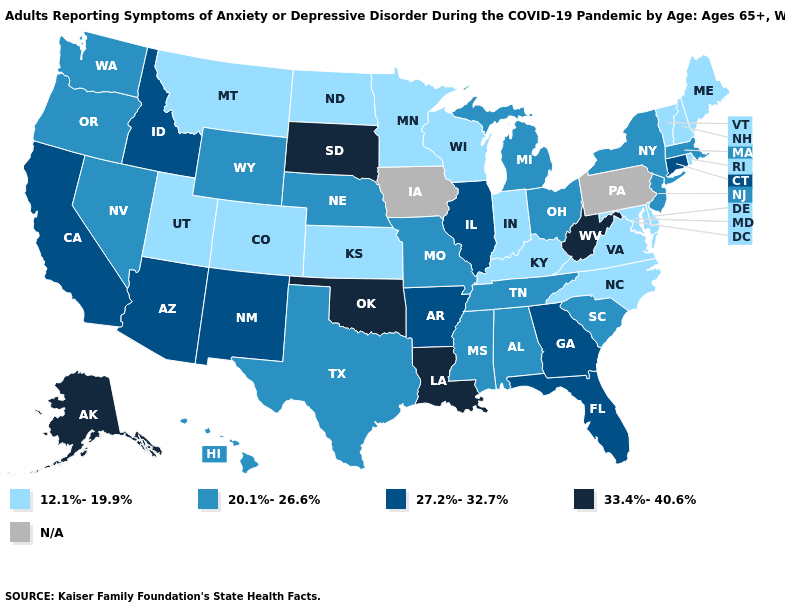How many symbols are there in the legend?
Be succinct. 5. What is the value of Alabama?
Answer briefly. 20.1%-26.6%. What is the value of New York?
Be succinct. 20.1%-26.6%. What is the value of New Hampshire?
Quick response, please. 12.1%-19.9%. What is the highest value in the USA?
Keep it brief. 33.4%-40.6%. What is the lowest value in the West?
Write a very short answer. 12.1%-19.9%. What is the highest value in the USA?
Write a very short answer. 33.4%-40.6%. What is the value of South Dakota?
Be succinct. 33.4%-40.6%. Which states have the lowest value in the West?
Short answer required. Colorado, Montana, Utah. Is the legend a continuous bar?
Keep it brief. No. What is the value of Oregon?
Write a very short answer. 20.1%-26.6%. What is the value of North Carolina?
Short answer required. 12.1%-19.9%. Is the legend a continuous bar?
Write a very short answer. No. Does Oklahoma have the highest value in the South?
Quick response, please. Yes. 